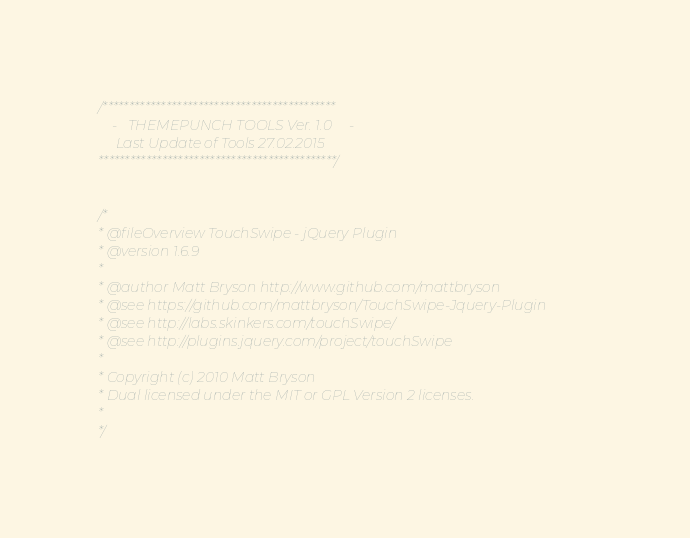<code> <loc_0><loc_0><loc_500><loc_500><_JavaScript_>/********************************************
	-	THEMEPUNCH TOOLS Ver. 1.0     -
	 Last Update of Tools 27.02.2015
*********************************************/


/*
* @fileOverview TouchSwipe - jQuery Plugin
* @version 1.6.9
*
* @author Matt Bryson http://www.github.com/mattbryson
* @see https://github.com/mattbryson/TouchSwipe-Jquery-Plugin
* @see http://labs.skinkers.com/touchSwipe/
* @see http://plugins.jquery.com/project/touchSwipe
*
* Copyright (c) 2010 Matt Bryson
* Dual licensed under the MIT or GPL Version 2 licenses.
*
*/


</code> 